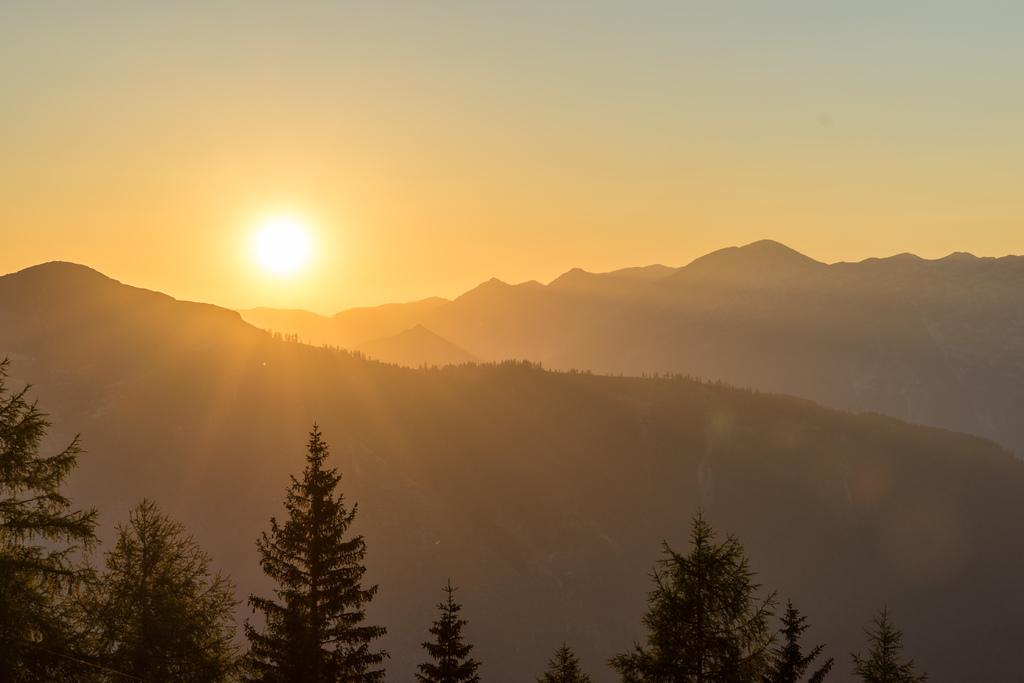What type of natural environment is depicted in the image? The image features many trees and mountains in the background. What celestial body is visible in the sky? The sun is observable in the sky. What type of riddle can be solved by observing the trees in the image? There is no riddle present in the image, as it simply depicts a natural environment with trees and mountains. 